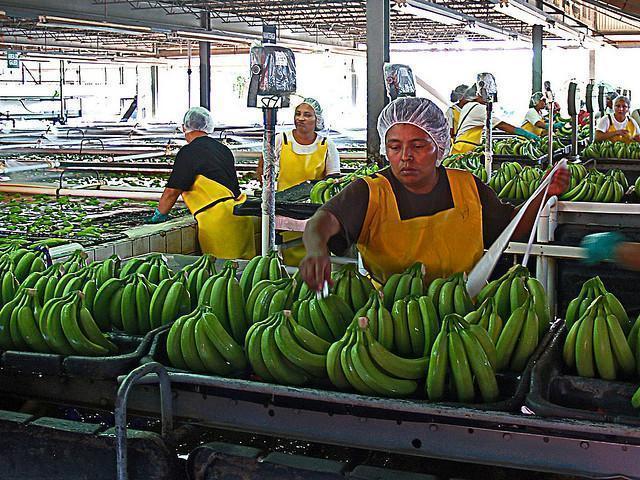What does the hair cap prevent?
Make your selection and explain in format: 'Answer: answer
Rationale: rationale.'
Options: Flies, dandruff, stray hairs, distraction. Answer: stray hairs.
Rationale: A woman wears a hair cap while handling produce. people wear hair nets in the food industry for cleanliness. 